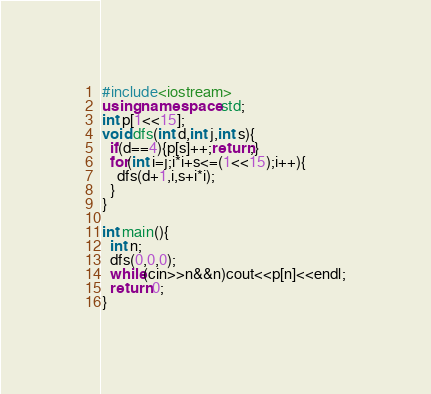<code> <loc_0><loc_0><loc_500><loc_500><_C++_>#include<iostream>
using namespace std;
int p[1<<15];
void dfs(int d,int j,int s){
  if(d==4){p[s]++;return;}
  for(int i=j;i*i+s<=(1<<15);i++){
    dfs(d+1,i,s+i*i);
  }
}

int main(){
  int n;
  dfs(0,0,0);
  while(cin>>n&&n)cout<<p[n]<<endl;
  return 0;
}</code> 